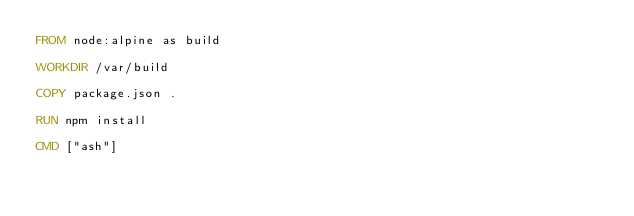<code> <loc_0><loc_0><loc_500><loc_500><_Dockerfile_>FROM node:alpine as build

WORKDIR /var/build

COPY package.json .

RUN npm install

CMD ["ash"]</code> 